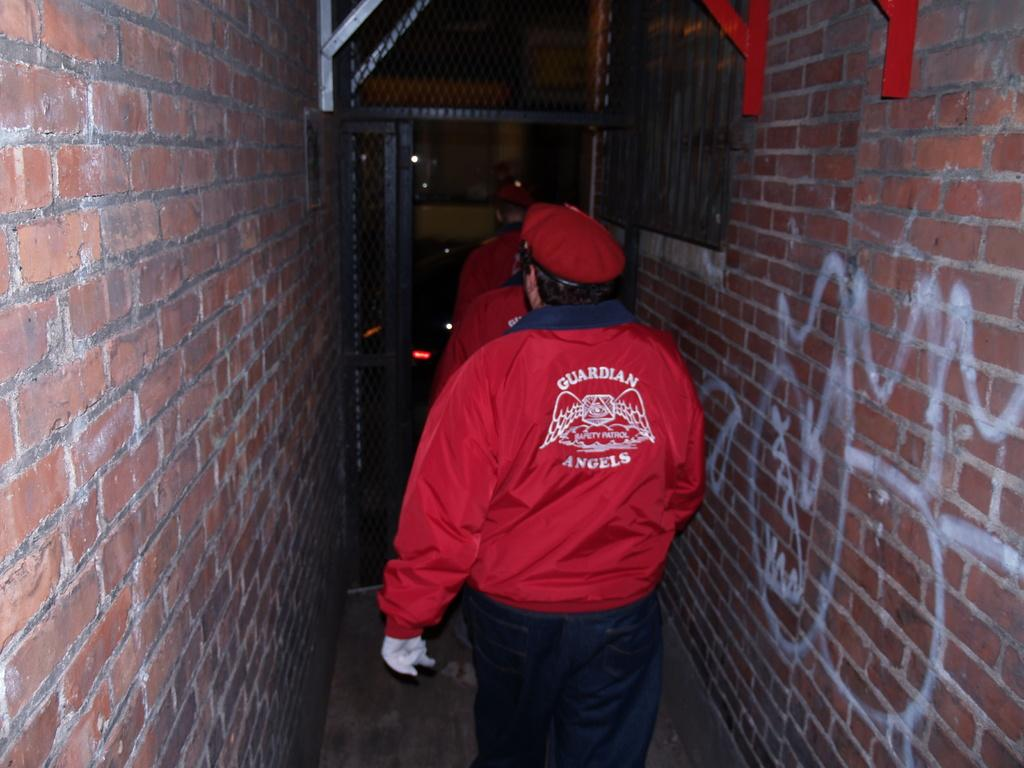What can be seen in the image? There is a group of guards in the image. What are the guards doing in the image? The guards are moving between two walls in the image. What are the walls made of? The walls are constructed with bricks. What type of string is being used by the guards to climb the walls in the image? There is no string visible in the image, and the guards are not climbing the walls. 